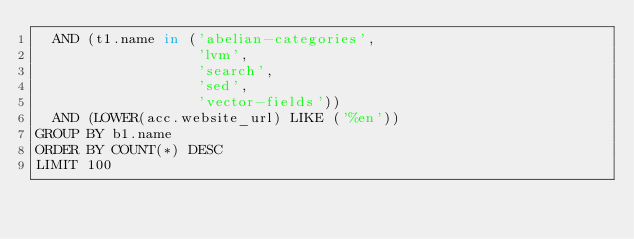Convert code to text. <code><loc_0><loc_0><loc_500><loc_500><_SQL_>  AND (t1.name in ('abelian-categories',
                   'lvm',
                   'search',
                   'sed',
                   'vector-fields'))
  AND (LOWER(acc.website_url) LIKE ('%en'))
GROUP BY b1.name
ORDER BY COUNT(*) DESC
LIMIT 100</code> 